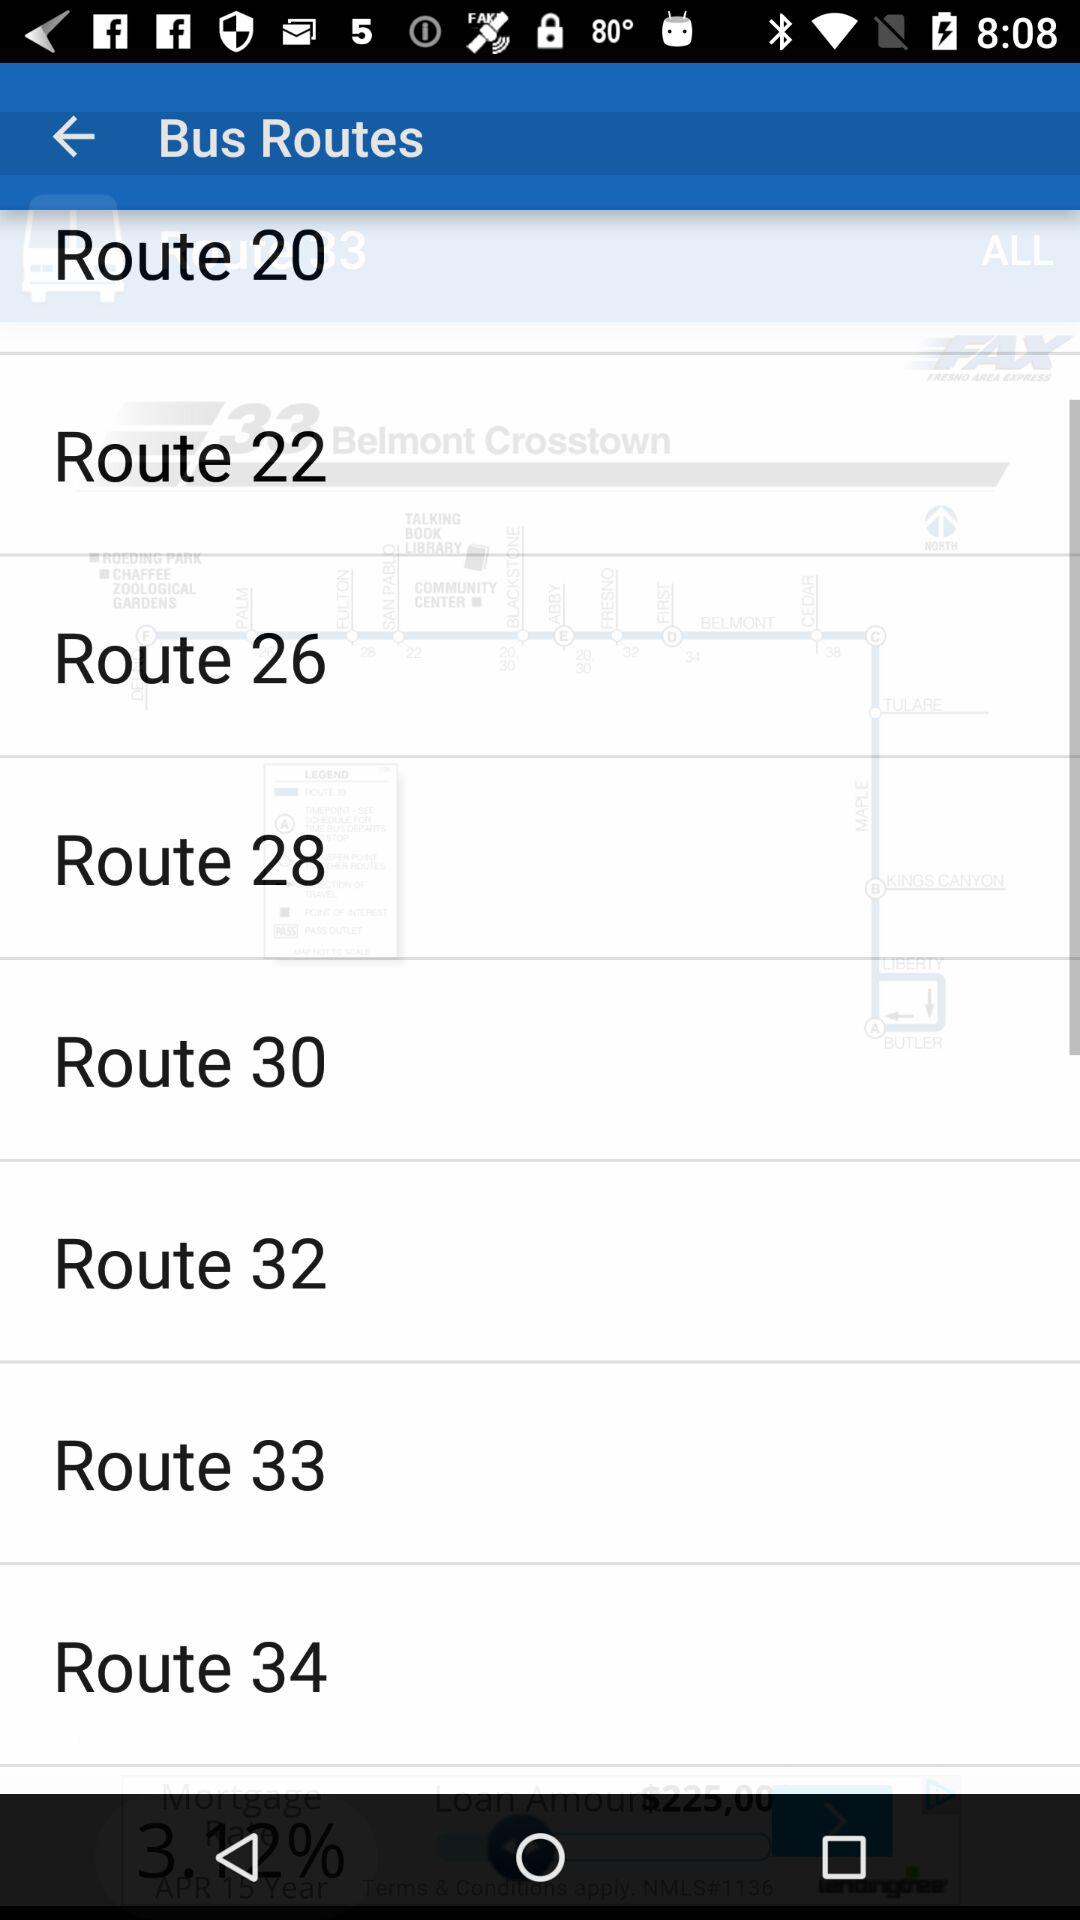How many routes are displayed on the screen?
Answer the question using a single word or phrase. 8 